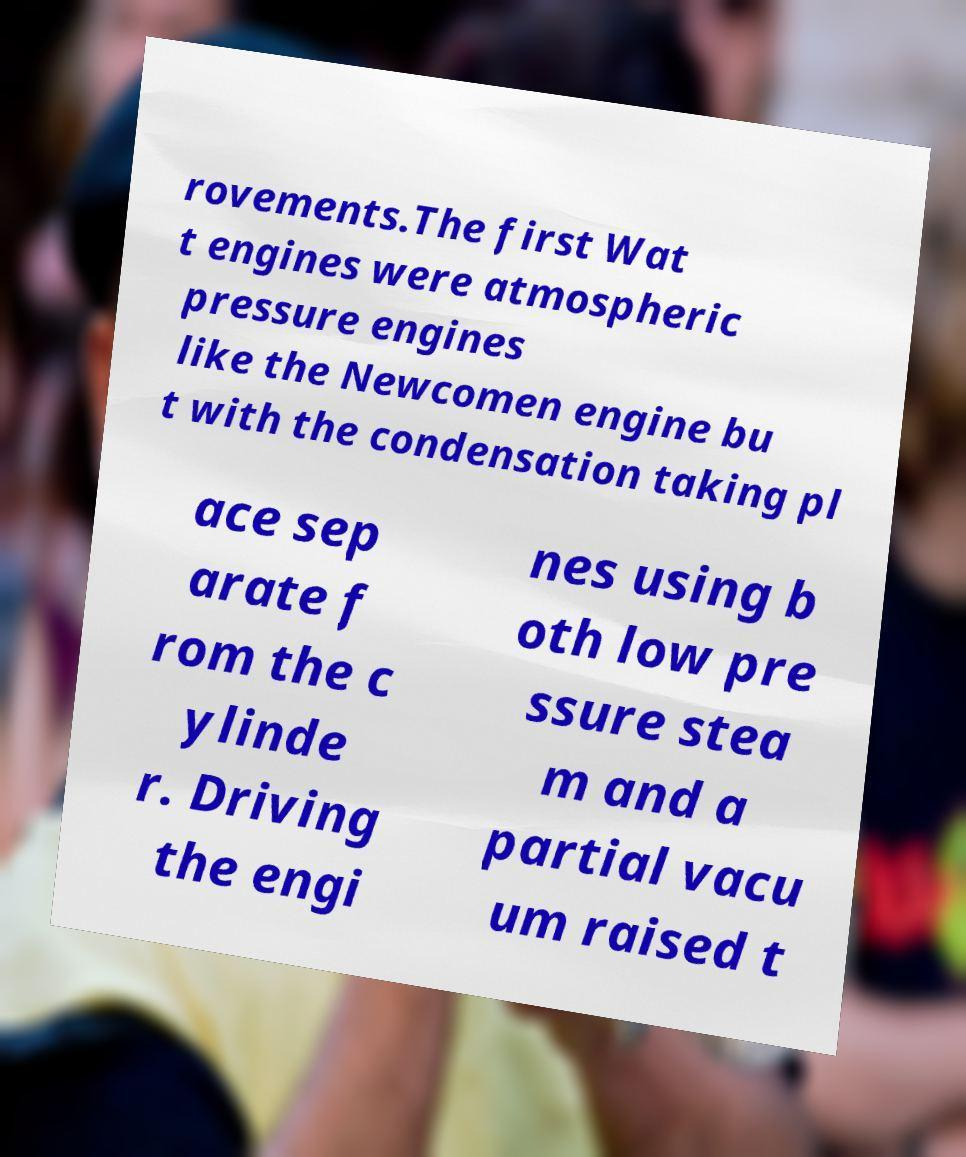Please read and relay the text visible in this image. What does it say? rovements.The first Wat t engines were atmospheric pressure engines like the Newcomen engine bu t with the condensation taking pl ace sep arate f rom the c ylinde r. Driving the engi nes using b oth low pre ssure stea m and a partial vacu um raised t 